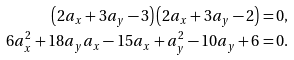<formula> <loc_0><loc_0><loc_500><loc_500>\left ( 2 a _ { x } + 3 a _ { y } - 3 \right ) \left ( 2 a _ { x } + 3 a _ { y } - 2 \right ) & = 0 , \\ 6 a _ { x } ^ { 2 } + 1 8 a _ { y } a _ { x } - 1 5 a _ { x } + a _ { y } ^ { 2 } - 1 0 a _ { y } + 6 & = 0 .</formula> 